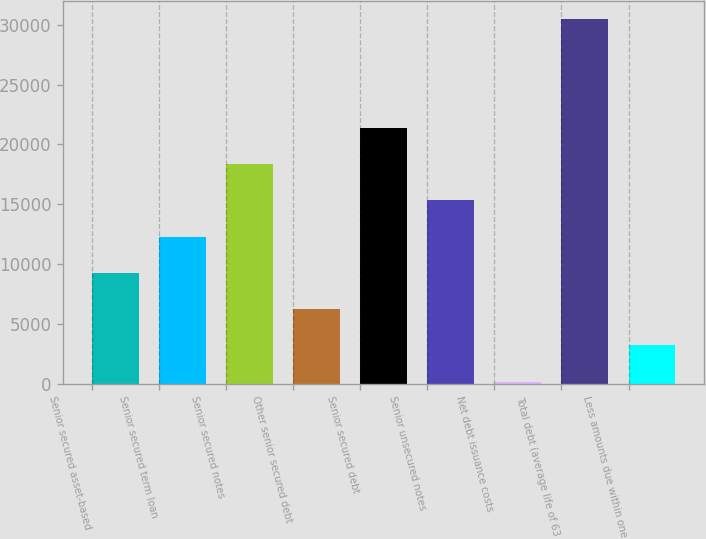<chart> <loc_0><loc_0><loc_500><loc_500><bar_chart><fcel>Senior secured asset-based<fcel>Senior secured term loan<fcel>Senior secured notes<fcel>Other senior secured debt<fcel>Senior secured debt<fcel>Senior unsecured notes<fcel>Net debt issuance costs<fcel>Total debt (average life of 63<fcel>Less amounts due within one<nl><fcel>9263.3<fcel>12295.4<fcel>18359.6<fcel>6231.2<fcel>21391.7<fcel>15327.5<fcel>167<fcel>30488<fcel>3199.1<nl></chart> 